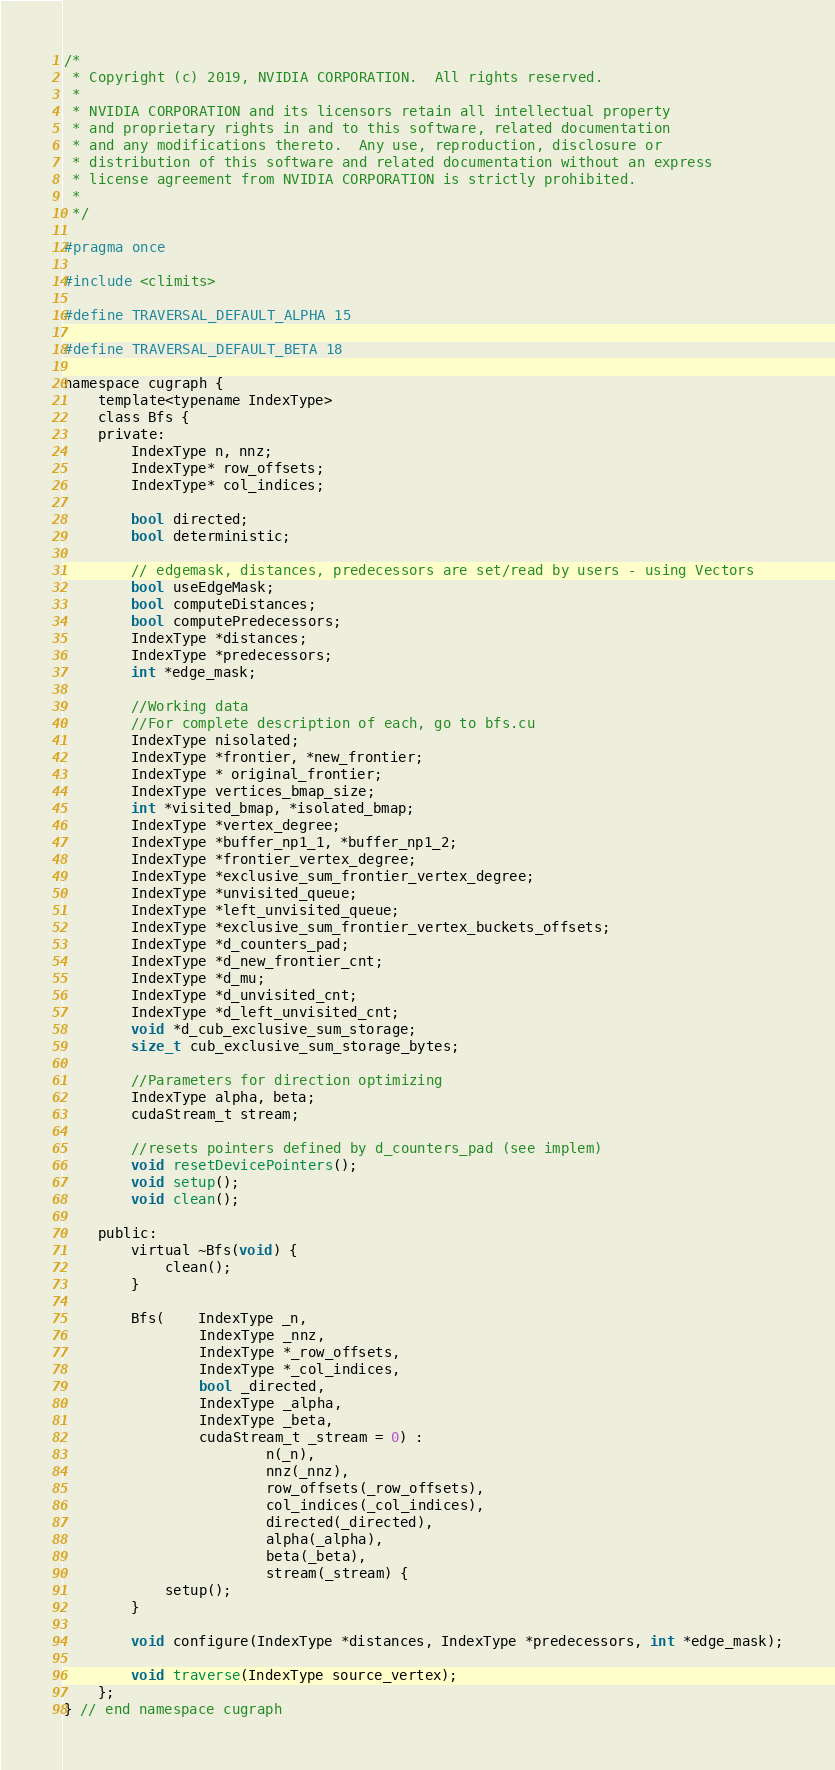<code> <loc_0><loc_0><loc_500><loc_500><_Cuda_>/*
 * Copyright (c) 2019, NVIDIA CORPORATION.  All rights reserved.
 *
 * NVIDIA CORPORATION and its licensors retain all intellectual property
 * and proprietary rights in and to this software, related documentation
 * and any modifications thereto.  Any use, reproduction, disclosure or
 * distribution of this software and related documentation without an express
 * license agreement from NVIDIA CORPORATION is strictly prohibited.
 *
 */

#pragma once

#include <climits> 

#define TRAVERSAL_DEFAULT_ALPHA 15

#define TRAVERSAL_DEFAULT_BETA 18

namespace cugraph {
	template<typename IndexType>
	class Bfs {
	private:
		IndexType n, nnz;
		IndexType* row_offsets;
		IndexType* col_indices;

		bool directed;
		bool deterministic;

		// edgemask, distances, predecessors are set/read by users - using Vectors
		bool useEdgeMask;
		bool computeDistances;
		bool computePredecessors;
		IndexType *distances;
		IndexType *predecessors;
		int *edge_mask;

		//Working data
		//For complete description of each, go to bfs.cu
		IndexType nisolated;
		IndexType *frontier, *new_frontier;
		IndexType * original_frontier;
		IndexType vertices_bmap_size;
		int *visited_bmap, *isolated_bmap;
		IndexType *vertex_degree;
		IndexType *buffer_np1_1, *buffer_np1_2;
		IndexType *frontier_vertex_degree;
		IndexType *exclusive_sum_frontier_vertex_degree;
		IndexType *unvisited_queue;
		IndexType *left_unvisited_queue;
		IndexType *exclusive_sum_frontier_vertex_buckets_offsets;
		IndexType *d_counters_pad;
		IndexType *d_new_frontier_cnt;
		IndexType *d_mu;
		IndexType *d_unvisited_cnt;
		IndexType *d_left_unvisited_cnt;
		void *d_cub_exclusive_sum_storage;
		size_t cub_exclusive_sum_storage_bytes;

		//Parameters for direction optimizing
		IndexType alpha, beta;
		cudaStream_t stream;

		//resets pointers defined by d_counters_pad (see implem)
		void resetDevicePointers();
		void setup();
		void clean();

	public:
		virtual ~Bfs(void) {
			clean();
		}

		Bfs(	IndexType _n,
				IndexType _nnz,
				IndexType *_row_offsets,
				IndexType *_col_indices,
				bool _directed,
				IndexType _alpha,
				IndexType _beta,
				cudaStream_t _stream = 0) :
						n(_n),
						nnz(_nnz),
						row_offsets(_row_offsets),
						col_indices(_col_indices),
						directed(_directed),
						alpha(_alpha),
						beta(_beta),
						stream(_stream) {
			setup();
		}

		void configure(IndexType *distances, IndexType *predecessors, int *edge_mask);

		void traverse(IndexType source_vertex);
	};
} // end namespace cugraph

</code> 